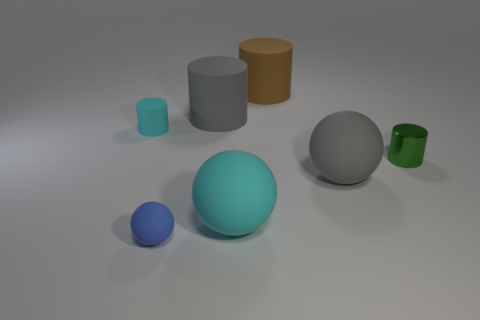Subtract all small metallic cylinders. How many cylinders are left? 3 Add 1 big cyan matte objects. How many objects exist? 8 Add 5 tiny things. How many tiny things are left? 8 Add 7 big shiny spheres. How many big shiny spheres exist? 7 Subtract all gray balls. How many balls are left? 2 Subtract 0 purple cylinders. How many objects are left? 7 Subtract all cylinders. How many objects are left? 3 Subtract all cyan cylinders. Subtract all yellow spheres. How many cylinders are left? 3 Subtract all purple cubes. How many gray balls are left? 1 Subtract all tiny metallic things. Subtract all cyan objects. How many objects are left? 4 